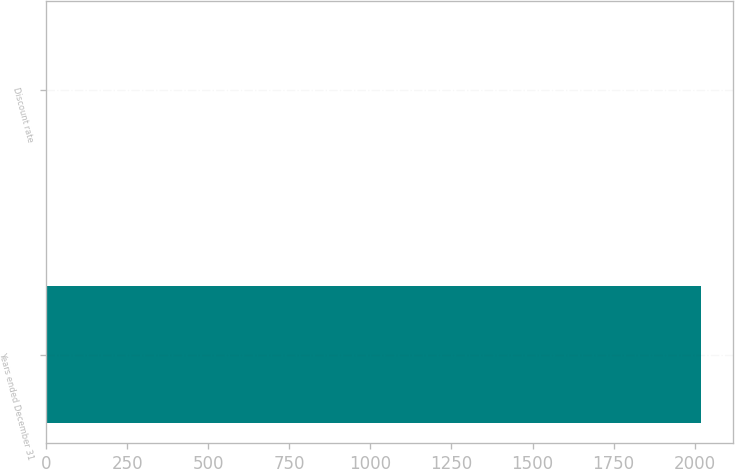<chart> <loc_0><loc_0><loc_500><loc_500><bar_chart><fcel>Years ended December 31<fcel>Discount rate<nl><fcel>2018<fcel>2.36<nl></chart> 